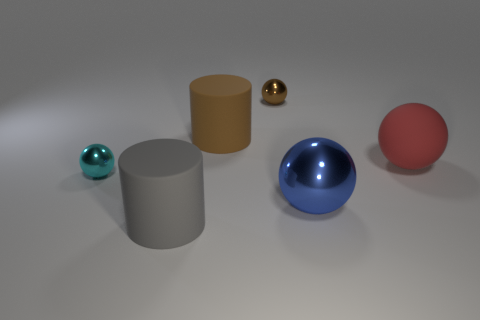Are there any other things that are the same shape as the small cyan metallic thing?
Provide a succinct answer. Yes. How many metallic objects are large red cylinders or red balls?
Your answer should be compact. 0. Are there fewer blue metal objects that are in front of the big shiny ball than tiny cyan things?
Make the answer very short. Yes. There is a blue object right of the matte cylinder that is left of the big rubber cylinder that is behind the blue thing; what shape is it?
Give a very brief answer. Sphere. Do the large rubber ball and the big shiny ball have the same color?
Your answer should be very brief. No. Is the number of big cyan metallic blocks greater than the number of large shiny balls?
Give a very brief answer. No. How many other objects are the same material as the tiny brown ball?
Your response must be concise. 2. What number of things are large green balls or metal spheres that are behind the small cyan ball?
Make the answer very short. 1. Are there fewer big green matte cylinders than gray matte things?
Ensure brevity in your answer.  Yes. What color is the ball in front of the ball to the left of the small metallic object that is on the right side of the small cyan thing?
Your response must be concise. Blue. 